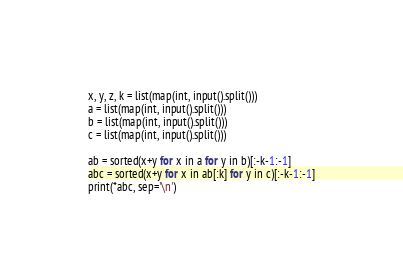<code> <loc_0><loc_0><loc_500><loc_500><_Python_>x, y, z, k = list(map(int, input().split()))
a = list(map(int, input().split()))
b = list(map(int, input().split()))
c = list(map(int, input().split()))

ab = sorted(x+y for x in a for y in b)[:-k-1:-1]
abc = sorted(x+y for x in ab[:k] for y in c)[:-k-1:-1]
print(*abc, sep='\n')</code> 